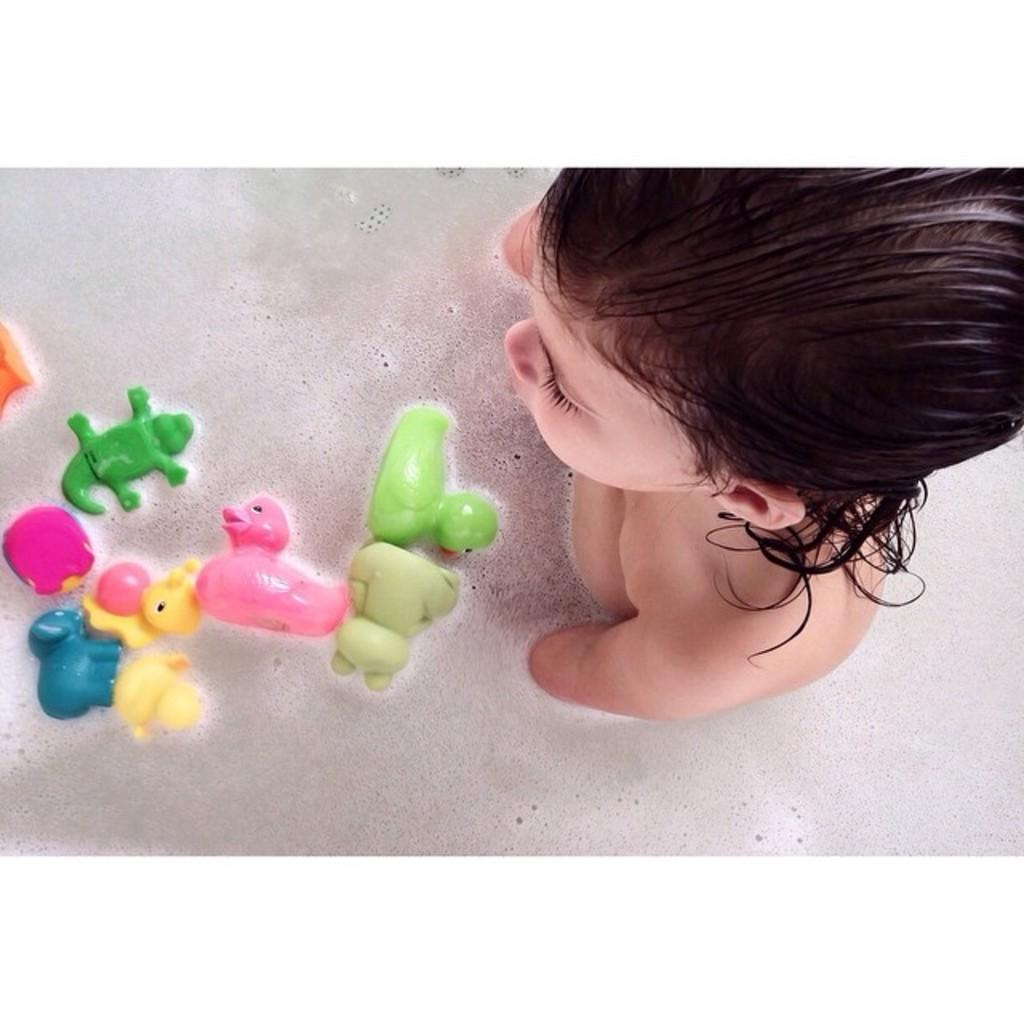What is the baby doing in the image? There is a baby in the water in the image. What else can be seen in the water besides the baby? There are toys on the water. What is the appearance of the water in the image? Soap foam is present on the water. What type of flowers can be seen growing near the baby in the image? There are no flowers present in the image; it features a baby in the water with toys and soap foam. 